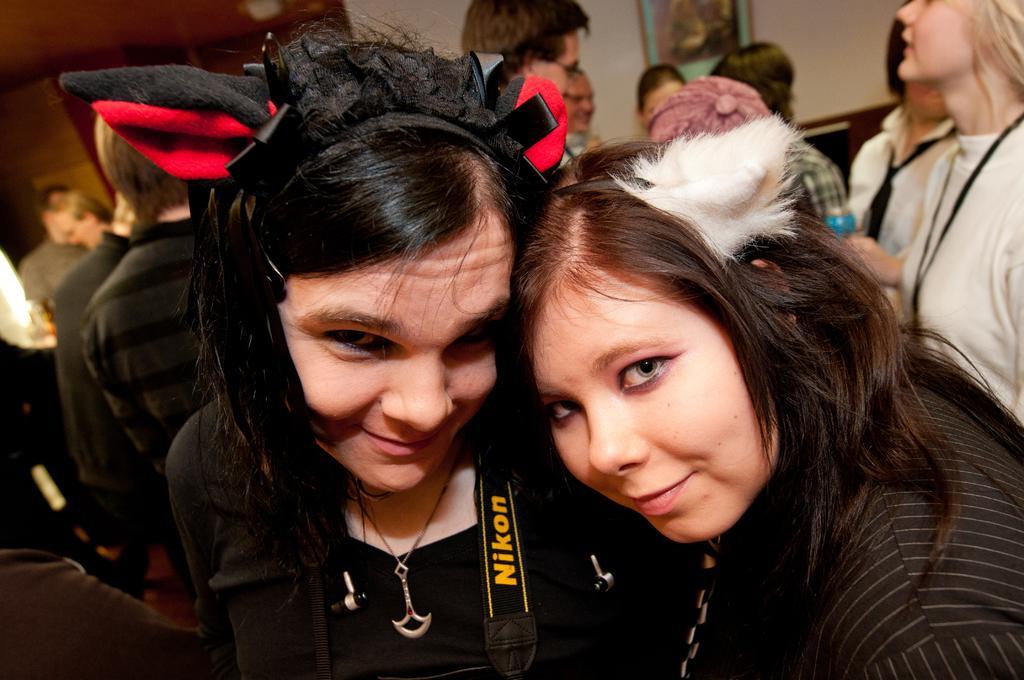Could you give a brief overview of what you see in this image? In this image, we can see a group of people wearing clothes. There are two persons in the middle of the image wearing bunny ears. 